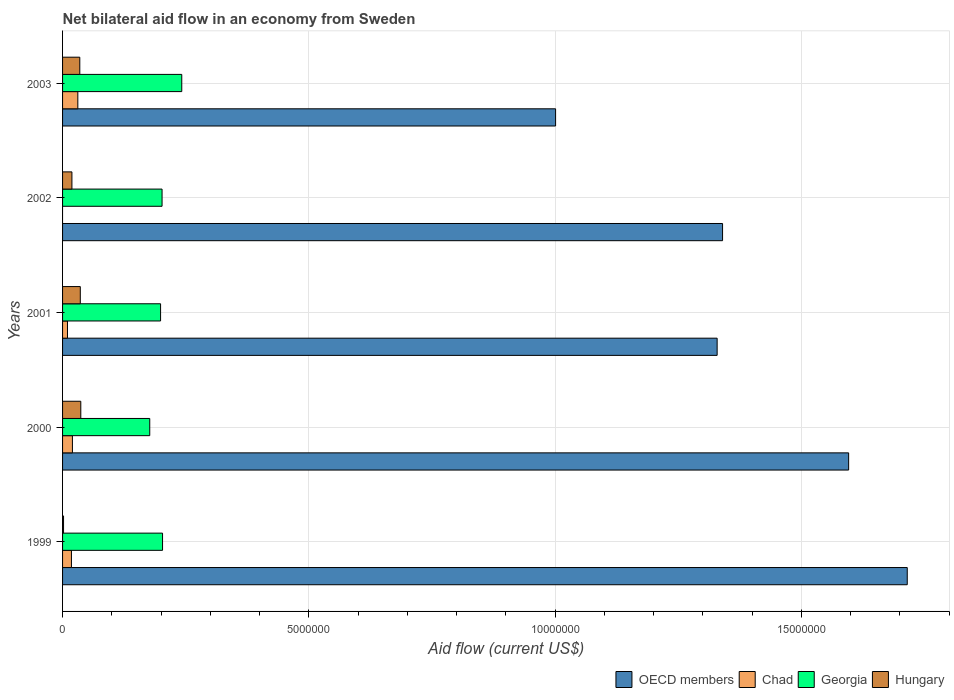Are the number of bars on each tick of the Y-axis equal?
Give a very brief answer. No. How many bars are there on the 2nd tick from the top?
Your answer should be very brief. 3. How many bars are there on the 4th tick from the bottom?
Offer a terse response. 3. Across all years, what is the maximum net bilateral aid flow in OECD members?
Keep it short and to the point. 1.72e+07. Across all years, what is the minimum net bilateral aid flow in Chad?
Keep it short and to the point. 0. What is the total net bilateral aid flow in Georgia in the graph?
Offer a terse response. 1.02e+07. What is the difference between the net bilateral aid flow in OECD members in 2000 and that in 2002?
Offer a terse response. 2.56e+06. What is the difference between the net bilateral aid flow in OECD members in 2001 and the net bilateral aid flow in Georgia in 2002?
Provide a short and direct response. 1.13e+07. What is the average net bilateral aid flow in Georgia per year?
Offer a terse response. 2.05e+06. In the year 2003, what is the difference between the net bilateral aid flow in Georgia and net bilateral aid flow in Hungary?
Keep it short and to the point. 2.07e+06. In how many years, is the net bilateral aid flow in Chad greater than 7000000 US$?
Ensure brevity in your answer.  0. What is the ratio of the net bilateral aid flow in OECD members in 2002 to that in 2003?
Make the answer very short. 1.34. Is the net bilateral aid flow in OECD members in 2000 less than that in 2003?
Provide a short and direct response. No. What is the difference between the highest and the lowest net bilateral aid flow in OECD members?
Your answer should be very brief. 7.14e+06. Is the sum of the net bilateral aid flow in Georgia in 2000 and 2002 greater than the maximum net bilateral aid flow in Chad across all years?
Give a very brief answer. Yes. Is it the case that in every year, the sum of the net bilateral aid flow in Hungary and net bilateral aid flow in Chad is greater than the sum of net bilateral aid flow in OECD members and net bilateral aid flow in Georgia?
Keep it short and to the point. No. How many bars are there?
Your response must be concise. 19. Are the values on the major ticks of X-axis written in scientific E-notation?
Provide a short and direct response. No. What is the title of the graph?
Make the answer very short. Net bilateral aid flow in an economy from Sweden. What is the label or title of the X-axis?
Ensure brevity in your answer.  Aid flow (current US$). What is the Aid flow (current US$) of OECD members in 1999?
Offer a very short reply. 1.72e+07. What is the Aid flow (current US$) in Georgia in 1999?
Keep it short and to the point. 2.03e+06. What is the Aid flow (current US$) of Hungary in 1999?
Provide a succinct answer. 2.00e+04. What is the Aid flow (current US$) of OECD members in 2000?
Offer a terse response. 1.60e+07. What is the Aid flow (current US$) of Georgia in 2000?
Your answer should be very brief. 1.77e+06. What is the Aid flow (current US$) in Hungary in 2000?
Keep it short and to the point. 3.70e+05. What is the Aid flow (current US$) in OECD members in 2001?
Your response must be concise. 1.33e+07. What is the Aid flow (current US$) in Chad in 2001?
Offer a terse response. 1.00e+05. What is the Aid flow (current US$) in Georgia in 2001?
Provide a short and direct response. 1.99e+06. What is the Aid flow (current US$) in Hungary in 2001?
Your response must be concise. 3.60e+05. What is the Aid flow (current US$) in OECD members in 2002?
Your response must be concise. 1.34e+07. What is the Aid flow (current US$) of Chad in 2002?
Make the answer very short. 0. What is the Aid flow (current US$) in Georgia in 2002?
Your answer should be compact. 2.02e+06. What is the Aid flow (current US$) of Hungary in 2002?
Provide a succinct answer. 1.90e+05. What is the Aid flow (current US$) in OECD members in 2003?
Your response must be concise. 1.00e+07. What is the Aid flow (current US$) of Georgia in 2003?
Your answer should be compact. 2.42e+06. What is the Aid flow (current US$) of Hungary in 2003?
Offer a very short reply. 3.50e+05. Across all years, what is the maximum Aid flow (current US$) of OECD members?
Ensure brevity in your answer.  1.72e+07. Across all years, what is the maximum Aid flow (current US$) of Georgia?
Your response must be concise. 2.42e+06. Across all years, what is the minimum Aid flow (current US$) in OECD members?
Provide a short and direct response. 1.00e+07. Across all years, what is the minimum Aid flow (current US$) of Georgia?
Ensure brevity in your answer.  1.77e+06. What is the total Aid flow (current US$) in OECD members in the graph?
Make the answer very short. 6.98e+07. What is the total Aid flow (current US$) in Chad in the graph?
Give a very brief answer. 7.90e+05. What is the total Aid flow (current US$) in Georgia in the graph?
Your response must be concise. 1.02e+07. What is the total Aid flow (current US$) in Hungary in the graph?
Ensure brevity in your answer.  1.29e+06. What is the difference between the Aid flow (current US$) of OECD members in 1999 and that in 2000?
Your response must be concise. 1.19e+06. What is the difference between the Aid flow (current US$) of Chad in 1999 and that in 2000?
Ensure brevity in your answer.  -2.00e+04. What is the difference between the Aid flow (current US$) in Georgia in 1999 and that in 2000?
Make the answer very short. 2.60e+05. What is the difference between the Aid flow (current US$) of Hungary in 1999 and that in 2000?
Make the answer very short. -3.50e+05. What is the difference between the Aid flow (current US$) in OECD members in 1999 and that in 2001?
Offer a very short reply. 3.86e+06. What is the difference between the Aid flow (current US$) in Chad in 1999 and that in 2001?
Offer a very short reply. 8.00e+04. What is the difference between the Aid flow (current US$) in Hungary in 1999 and that in 2001?
Your response must be concise. -3.40e+05. What is the difference between the Aid flow (current US$) in OECD members in 1999 and that in 2002?
Ensure brevity in your answer.  3.75e+06. What is the difference between the Aid flow (current US$) of OECD members in 1999 and that in 2003?
Make the answer very short. 7.14e+06. What is the difference between the Aid flow (current US$) in Georgia in 1999 and that in 2003?
Keep it short and to the point. -3.90e+05. What is the difference between the Aid flow (current US$) of Hungary in 1999 and that in 2003?
Your answer should be very brief. -3.30e+05. What is the difference between the Aid flow (current US$) of OECD members in 2000 and that in 2001?
Your answer should be compact. 2.67e+06. What is the difference between the Aid flow (current US$) in Hungary in 2000 and that in 2001?
Your answer should be compact. 10000. What is the difference between the Aid flow (current US$) in OECD members in 2000 and that in 2002?
Offer a very short reply. 2.56e+06. What is the difference between the Aid flow (current US$) of Georgia in 2000 and that in 2002?
Your answer should be compact. -2.50e+05. What is the difference between the Aid flow (current US$) in OECD members in 2000 and that in 2003?
Your response must be concise. 5.95e+06. What is the difference between the Aid flow (current US$) in Georgia in 2000 and that in 2003?
Offer a very short reply. -6.50e+05. What is the difference between the Aid flow (current US$) in Hungary in 2000 and that in 2003?
Your response must be concise. 2.00e+04. What is the difference between the Aid flow (current US$) in Georgia in 2001 and that in 2002?
Your answer should be very brief. -3.00e+04. What is the difference between the Aid flow (current US$) in Hungary in 2001 and that in 2002?
Your response must be concise. 1.70e+05. What is the difference between the Aid flow (current US$) of OECD members in 2001 and that in 2003?
Ensure brevity in your answer.  3.28e+06. What is the difference between the Aid flow (current US$) in Georgia in 2001 and that in 2003?
Your response must be concise. -4.30e+05. What is the difference between the Aid flow (current US$) in OECD members in 2002 and that in 2003?
Your answer should be very brief. 3.39e+06. What is the difference between the Aid flow (current US$) of Georgia in 2002 and that in 2003?
Offer a terse response. -4.00e+05. What is the difference between the Aid flow (current US$) in OECD members in 1999 and the Aid flow (current US$) in Chad in 2000?
Provide a short and direct response. 1.70e+07. What is the difference between the Aid flow (current US$) in OECD members in 1999 and the Aid flow (current US$) in Georgia in 2000?
Ensure brevity in your answer.  1.54e+07. What is the difference between the Aid flow (current US$) in OECD members in 1999 and the Aid flow (current US$) in Hungary in 2000?
Your answer should be compact. 1.68e+07. What is the difference between the Aid flow (current US$) of Chad in 1999 and the Aid flow (current US$) of Georgia in 2000?
Offer a very short reply. -1.59e+06. What is the difference between the Aid flow (current US$) in Chad in 1999 and the Aid flow (current US$) in Hungary in 2000?
Give a very brief answer. -1.90e+05. What is the difference between the Aid flow (current US$) of Georgia in 1999 and the Aid flow (current US$) of Hungary in 2000?
Offer a terse response. 1.66e+06. What is the difference between the Aid flow (current US$) in OECD members in 1999 and the Aid flow (current US$) in Chad in 2001?
Ensure brevity in your answer.  1.70e+07. What is the difference between the Aid flow (current US$) in OECD members in 1999 and the Aid flow (current US$) in Georgia in 2001?
Your response must be concise. 1.52e+07. What is the difference between the Aid flow (current US$) in OECD members in 1999 and the Aid flow (current US$) in Hungary in 2001?
Give a very brief answer. 1.68e+07. What is the difference between the Aid flow (current US$) in Chad in 1999 and the Aid flow (current US$) in Georgia in 2001?
Make the answer very short. -1.81e+06. What is the difference between the Aid flow (current US$) of Georgia in 1999 and the Aid flow (current US$) of Hungary in 2001?
Offer a terse response. 1.67e+06. What is the difference between the Aid flow (current US$) of OECD members in 1999 and the Aid flow (current US$) of Georgia in 2002?
Provide a succinct answer. 1.51e+07. What is the difference between the Aid flow (current US$) of OECD members in 1999 and the Aid flow (current US$) of Hungary in 2002?
Provide a short and direct response. 1.70e+07. What is the difference between the Aid flow (current US$) in Chad in 1999 and the Aid flow (current US$) in Georgia in 2002?
Give a very brief answer. -1.84e+06. What is the difference between the Aid flow (current US$) of Georgia in 1999 and the Aid flow (current US$) of Hungary in 2002?
Provide a short and direct response. 1.84e+06. What is the difference between the Aid flow (current US$) in OECD members in 1999 and the Aid flow (current US$) in Chad in 2003?
Give a very brief answer. 1.68e+07. What is the difference between the Aid flow (current US$) in OECD members in 1999 and the Aid flow (current US$) in Georgia in 2003?
Your response must be concise. 1.47e+07. What is the difference between the Aid flow (current US$) in OECD members in 1999 and the Aid flow (current US$) in Hungary in 2003?
Keep it short and to the point. 1.68e+07. What is the difference between the Aid flow (current US$) of Chad in 1999 and the Aid flow (current US$) of Georgia in 2003?
Make the answer very short. -2.24e+06. What is the difference between the Aid flow (current US$) in Georgia in 1999 and the Aid flow (current US$) in Hungary in 2003?
Ensure brevity in your answer.  1.68e+06. What is the difference between the Aid flow (current US$) of OECD members in 2000 and the Aid flow (current US$) of Chad in 2001?
Provide a short and direct response. 1.59e+07. What is the difference between the Aid flow (current US$) in OECD members in 2000 and the Aid flow (current US$) in Georgia in 2001?
Your answer should be compact. 1.40e+07. What is the difference between the Aid flow (current US$) of OECD members in 2000 and the Aid flow (current US$) of Hungary in 2001?
Ensure brevity in your answer.  1.56e+07. What is the difference between the Aid flow (current US$) of Chad in 2000 and the Aid flow (current US$) of Georgia in 2001?
Provide a succinct answer. -1.79e+06. What is the difference between the Aid flow (current US$) in Chad in 2000 and the Aid flow (current US$) in Hungary in 2001?
Your answer should be very brief. -1.60e+05. What is the difference between the Aid flow (current US$) in Georgia in 2000 and the Aid flow (current US$) in Hungary in 2001?
Give a very brief answer. 1.41e+06. What is the difference between the Aid flow (current US$) in OECD members in 2000 and the Aid flow (current US$) in Georgia in 2002?
Offer a very short reply. 1.39e+07. What is the difference between the Aid flow (current US$) in OECD members in 2000 and the Aid flow (current US$) in Hungary in 2002?
Provide a short and direct response. 1.58e+07. What is the difference between the Aid flow (current US$) of Chad in 2000 and the Aid flow (current US$) of Georgia in 2002?
Keep it short and to the point. -1.82e+06. What is the difference between the Aid flow (current US$) of Chad in 2000 and the Aid flow (current US$) of Hungary in 2002?
Your response must be concise. 10000. What is the difference between the Aid flow (current US$) in Georgia in 2000 and the Aid flow (current US$) in Hungary in 2002?
Offer a very short reply. 1.58e+06. What is the difference between the Aid flow (current US$) in OECD members in 2000 and the Aid flow (current US$) in Chad in 2003?
Keep it short and to the point. 1.56e+07. What is the difference between the Aid flow (current US$) in OECD members in 2000 and the Aid flow (current US$) in Georgia in 2003?
Your answer should be very brief. 1.35e+07. What is the difference between the Aid flow (current US$) in OECD members in 2000 and the Aid flow (current US$) in Hungary in 2003?
Ensure brevity in your answer.  1.56e+07. What is the difference between the Aid flow (current US$) of Chad in 2000 and the Aid flow (current US$) of Georgia in 2003?
Give a very brief answer. -2.22e+06. What is the difference between the Aid flow (current US$) of Georgia in 2000 and the Aid flow (current US$) of Hungary in 2003?
Offer a very short reply. 1.42e+06. What is the difference between the Aid flow (current US$) of OECD members in 2001 and the Aid flow (current US$) of Georgia in 2002?
Keep it short and to the point. 1.13e+07. What is the difference between the Aid flow (current US$) in OECD members in 2001 and the Aid flow (current US$) in Hungary in 2002?
Your answer should be compact. 1.31e+07. What is the difference between the Aid flow (current US$) of Chad in 2001 and the Aid flow (current US$) of Georgia in 2002?
Provide a succinct answer. -1.92e+06. What is the difference between the Aid flow (current US$) in Chad in 2001 and the Aid flow (current US$) in Hungary in 2002?
Ensure brevity in your answer.  -9.00e+04. What is the difference between the Aid flow (current US$) in Georgia in 2001 and the Aid flow (current US$) in Hungary in 2002?
Provide a short and direct response. 1.80e+06. What is the difference between the Aid flow (current US$) in OECD members in 2001 and the Aid flow (current US$) in Chad in 2003?
Your response must be concise. 1.30e+07. What is the difference between the Aid flow (current US$) in OECD members in 2001 and the Aid flow (current US$) in Georgia in 2003?
Provide a succinct answer. 1.09e+07. What is the difference between the Aid flow (current US$) in OECD members in 2001 and the Aid flow (current US$) in Hungary in 2003?
Keep it short and to the point. 1.29e+07. What is the difference between the Aid flow (current US$) in Chad in 2001 and the Aid flow (current US$) in Georgia in 2003?
Make the answer very short. -2.32e+06. What is the difference between the Aid flow (current US$) in Chad in 2001 and the Aid flow (current US$) in Hungary in 2003?
Ensure brevity in your answer.  -2.50e+05. What is the difference between the Aid flow (current US$) in Georgia in 2001 and the Aid flow (current US$) in Hungary in 2003?
Ensure brevity in your answer.  1.64e+06. What is the difference between the Aid flow (current US$) in OECD members in 2002 and the Aid flow (current US$) in Chad in 2003?
Your answer should be very brief. 1.31e+07. What is the difference between the Aid flow (current US$) of OECD members in 2002 and the Aid flow (current US$) of Georgia in 2003?
Offer a terse response. 1.10e+07. What is the difference between the Aid flow (current US$) in OECD members in 2002 and the Aid flow (current US$) in Hungary in 2003?
Provide a short and direct response. 1.30e+07. What is the difference between the Aid flow (current US$) in Georgia in 2002 and the Aid flow (current US$) in Hungary in 2003?
Ensure brevity in your answer.  1.67e+06. What is the average Aid flow (current US$) of OECD members per year?
Give a very brief answer. 1.40e+07. What is the average Aid flow (current US$) in Chad per year?
Give a very brief answer. 1.58e+05. What is the average Aid flow (current US$) of Georgia per year?
Your answer should be compact. 2.05e+06. What is the average Aid flow (current US$) of Hungary per year?
Your answer should be compact. 2.58e+05. In the year 1999, what is the difference between the Aid flow (current US$) in OECD members and Aid flow (current US$) in Chad?
Your response must be concise. 1.70e+07. In the year 1999, what is the difference between the Aid flow (current US$) of OECD members and Aid flow (current US$) of Georgia?
Offer a terse response. 1.51e+07. In the year 1999, what is the difference between the Aid flow (current US$) of OECD members and Aid flow (current US$) of Hungary?
Offer a very short reply. 1.71e+07. In the year 1999, what is the difference between the Aid flow (current US$) of Chad and Aid flow (current US$) of Georgia?
Your answer should be very brief. -1.85e+06. In the year 1999, what is the difference between the Aid flow (current US$) of Chad and Aid flow (current US$) of Hungary?
Your answer should be compact. 1.60e+05. In the year 1999, what is the difference between the Aid flow (current US$) in Georgia and Aid flow (current US$) in Hungary?
Give a very brief answer. 2.01e+06. In the year 2000, what is the difference between the Aid flow (current US$) in OECD members and Aid flow (current US$) in Chad?
Offer a very short reply. 1.58e+07. In the year 2000, what is the difference between the Aid flow (current US$) in OECD members and Aid flow (current US$) in Georgia?
Your answer should be very brief. 1.42e+07. In the year 2000, what is the difference between the Aid flow (current US$) of OECD members and Aid flow (current US$) of Hungary?
Provide a short and direct response. 1.56e+07. In the year 2000, what is the difference between the Aid flow (current US$) of Chad and Aid flow (current US$) of Georgia?
Your answer should be compact. -1.57e+06. In the year 2000, what is the difference between the Aid flow (current US$) of Chad and Aid flow (current US$) of Hungary?
Your response must be concise. -1.70e+05. In the year 2000, what is the difference between the Aid flow (current US$) in Georgia and Aid flow (current US$) in Hungary?
Keep it short and to the point. 1.40e+06. In the year 2001, what is the difference between the Aid flow (current US$) in OECD members and Aid flow (current US$) in Chad?
Provide a short and direct response. 1.32e+07. In the year 2001, what is the difference between the Aid flow (current US$) of OECD members and Aid flow (current US$) of Georgia?
Your answer should be very brief. 1.13e+07. In the year 2001, what is the difference between the Aid flow (current US$) in OECD members and Aid flow (current US$) in Hungary?
Make the answer very short. 1.29e+07. In the year 2001, what is the difference between the Aid flow (current US$) in Chad and Aid flow (current US$) in Georgia?
Give a very brief answer. -1.89e+06. In the year 2001, what is the difference between the Aid flow (current US$) of Georgia and Aid flow (current US$) of Hungary?
Ensure brevity in your answer.  1.63e+06. In the year 2002, what is the difference between the Aid flow (current US$) in OECD members and Aid flow (current US$) in Georgia?
Your answer should be compact. 1.14e+07. In the year 2002, what is the difference between the Aid flow (current US$) of OECD members and Aid flow (current US$) of Hungary?
Your answer should be compact. 1.32e+07. In the year 2002, what is the difference between the Aid flow (current US$) of Georgia and Aid flow (current US$) of Hungary?
Keep it short and to the point. 1.83e+06. In the year 2003, what is the difference between the Aid flow (current US$) of OECD members and Aid flow (current US$) of Chad?
Offer a very short reply. 9.70e+06. In the year 2003, what is the difference between the Aid flow (current US$) of OECD members and Aid flow (current US$) of Georgia?
Keep it short and to the point. 7.59e+06. In the year 2003, what is the difference between the Aid flow (current US$) in OECD members and Aid flow (current US$) in Hungary?
Your answer should be very brief. 9.66e+06. In the year 2003, what is the difference between the Aid flow (current US$) in Chad and Aid flow (current US$) in Georgia?
Provide a short and direct response. -2.11e+06. In the year 2003, what is the difference between the Aid flow (current US$) of Georgia and Aid flow (current US$) of Hungary?
Keep it short and to the point. 2.07e+06. What is the ratio of the Aid flow (current US$) in OECD members in 1999 to that in 2000?
Give a very brief answer. 1.07. What is the ratio of the Aid flow (current US$) of Chad in 1999 to that in 2000?
Ensure brevity in your answer.  0.9. What is the ratio of the Aid flow (current US$) of Georgia in 1999 to that in 2000?
Give a very brief answer. 1.15. What is the ratio of the Aid flow (current US$) in Hungary in 1999 to that in 2000?
Your answer should be very brief. 0.05. What is the ratio of the Aid flow (current US$) in OECD members in 1999 to that in 2001?
Your response must be concise. 1.29. What is the ratio of the Aid flow (current US$) in Chad in 1999 to that in 2001?
Ensure brevity in your answer.  1.8. What is the ratio of the Aid flow (current US$) of Georgia in 1999 to that in 2001?
Ensure brevity in your answer.  1.02. What is the ratio of the Aid flow (current US$) of Hungary in 1999 to that in 2001?
Provide a short and direct response. 0.06. What is the ratio of the Aid flow (current US$) in OECD members in 1999 to that in 2002?
Provide a short and direct response. 1.28. What is the ratio of the Aid flow (current US$) in Georgia in 1999 to that in 2002?
Provide a succinct answer. 1. What is the ratio of the Aid flow (current US$) of Hungary in 1999 to that in 2002?
Your answer should be very brief. 0.11. What is the ratio of the Aid flow (current US$) of OECD members in 1999 to that in 2003?
Keep it short and to the point. 1.71. What is the ratio of the Aid flow (current US$) of Chad in 1999 to that in 2003?
Your response must be concise. 0.58. What is the ratio of the Aid flow (current US$) of Georgia in 1999 to that in 2003?
Give a very brief answer. 0.84. What is the ratio of the Aid flow (current US$) of Hungary in 1999 to that in 2003?
Your answer should be compact. 0.06. What is the ratio of the Aid flow (current US$) in OECD members in 2000 to that in 2001?
Give a very brief answer. 1.2. What is the ratio of the Aid flow (current US$) in Chad in 2000 to that in 2001?
Offer a terse response. 2. What is the ratio of the Aid flow (current US$) in Georgia in 2000 to that in 2001?
Your answer should be compact. 0.89. What is the ratio of the Aid flow (current US$) of Hungary in 2000 to that in 2001?
Your answer should be very brief. 1.03. What is the ratio of the Aid flow (current US$) in OECD members in 2000 to that in 2002?
Make the answer very short. 1.19. What is the ratio of the Aid flow (current US$) in Georgia in 2000 to that in 2002?
Provide a succinct answer. 0.88. What is the ratio of the Aid flow (current US$) of Hungary in 2000 to that in 2002?
Provide a succinct answer. 1.95. What is the ratio of the Aid flow (current US$) in OECD members in 2000 to that in 2003?
Your answer should be compact. 1.59. What is the ratio of the Aid flow (current US$) in Chad in 2000 to that in 2003?
Provide a short and direct response. 0.65. What is the ratio of the Aid flow (current US$) in Georgia in 2000 to that in 2003?
Provide a short and direct response. 0.73. What is the ratio of the Aid flow (current US$) in Hungary in 2000 to that in 2003?
Your response must be concise. 1.06. What is the ratio of the Aid flow (current US$) of Georgia in 2001 to that in 2002?
Offer a terse response. 0.99. What is the ratio of the Aid flow (current US$) in Hungary in 2001 to that in 2002?
Your answer should be compact. 1.89. What is the ratio of the Aid flow (current US$) of OECD members in 2001 to that in 2003?
Offer a very short reply. 1.33. What is the ratio of the Aid flow (current US$) in Chad in 2001 to that in 2003?
Make the answer very short. 0.32. What is the ratio of the Aid flow (current US$) of Georgia in 2001 to that in 2003?
Make the answer very short. 0.82. What is the ratio of the Aid flow (current US$) in Hungary in 2001 to that in 2003?
Your answer should be very brief. 1.03. What is the ratio of the Aid flow (current US$) in OECD members in 2002 to that in 2003?
Your answer should be compact. 1.34. What is the ratio of the Aid flow (current US$) of Georgia in 2002 to that in 2003?
Offer a very short reply. 0.83. What is the ratio of the Aid flow (current US$) in Hungary in 2002 to that in 2003?
Your answer should be very brief. 0.54. What is the difference between the highest and the second highest Aid flow (current US$) of OECD members?
Offer a very short reply. 1.19e+06. What is the difference between the highest and the second highest Aid flow (current US$) of Chad?
Ensure brevity in your answer.  1.10e+05. What is the difference between the highest and the second highest Aid flow (current US$) of Hungary?
Keep it short and to the point. 10000. What is the difference between the highest and the lowest Aid flow (current US$) of OECD members?
Provide a short and direct response. 7.14e+06. What is the difference between the highest and the lowest Aid flow (current US$) of Chad?
Keep it short and to the point. 3.10e+05. What is the difference between the highest and the lowest Aid flow (current US$) in Georgia?
Offer a terse response. 6.50e+05. What is the difference between the highest and the lowest Aid flow (current US$) of Hungary?
Make the answer very short. 3.50e+05. 